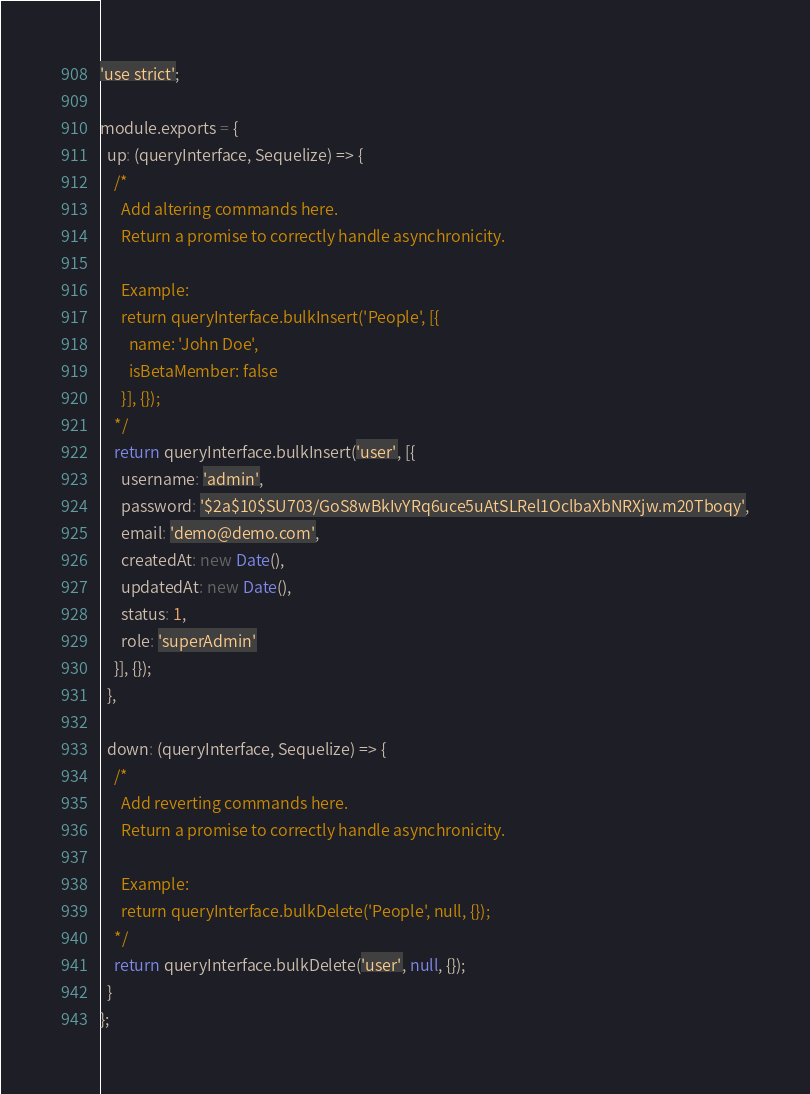<code> <loc_0><loc_0><loc_500><loc_500><_JavaScript_>'use strict';

module.exports = {
  up: (queryInterface, Sequelize) => {
    /*
      Add altering commands here.
      Return a promise to correctly handle asynchronicity.

      Example:
      return queryInterface.bulkInsert('People', [{
        name: 'John Doe',
        isBetaMember: false
      }], {});
    */
    return queryInterface.bulkInsert('user', [{
      username: 'admin',
      password: '$2a$10$SU703/GoS8wBkIvYRq6uce5uAtSLRel1OclbaXbNRXjw.m20Tboqy',
      email: 'demo@demo.com',
      createdAt: new Date(),
      updatedAt: new Date(),
      status: 1,
      role: 'superAdmin'
    }], {});
  },

  down: (queryInterface, Sequelize) => {
    /*
      Add reverting commands here.
      Return a promise to correctly handle asynchronicity.

      Example:
      return queryInterface.bulkDelete('People', null, {});
    */
    return queryInterface.bulkDelete('user', null, {});
  }
};
</code> 